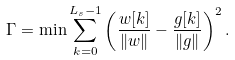Convert formula to latex. <formula><loc_0><loc_0><loc_500><loc_500>\Gamma = \min \sum _ { k = 0 } ^ { L _ { s } - 1 } \left ( \frac { w [ k ] } { \| w \| } - \frac { g [ k ] } { \| g \| } \right ) ^ { 2 } .</formula> 